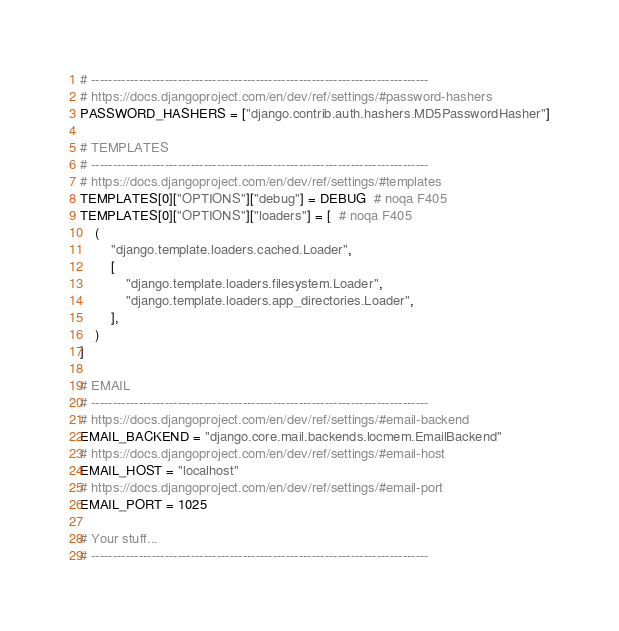<code> <loc_0><loc_0><loc_500><loc_500><_Python_># ------------------------------------------------------------------------------
# https://docs.djangoproject.com/en/dev/ref/settings/#password-hashers
PASSWORD_HASHERS = ["django.contrib.auth.hashers.MD5PasswordHasher"]

# TEMPLATES
# ------------------------------------------------------------------------------
# https://docs.djangoproject.com/en/dev/ref/settings/#templates
TEMPLATES[0]["OPTIONS"]["debug"] = DEBUG  # noqa F405
TEMPLATES[0]["OPTIONS"]["loaders"] = [  # noqa F405
    (
        "django.template.loaders.cached.Loader",
        [
            "django.template.loaders.filesystem.Loader",
            "django.template.loaders.app_directories.Loader",
        ],
    )
]

# EMAIL
# ------------------------------------------------------------------------------
# https://docs.djangoproject.com/en/dev/ref/settings/#email-backend
EMAIL_BACKEND = "django.core.mail.backends.locmem.EmailBackend"
# https://docs.djangoproject.com/en/dev/ref/settings/#email-host
EMAIL_HOST = "localhost"
# https://docs.djangoproject.com/en/dev/ref/settings/#email-port
EMAIL_PORT = 1025

# Your stuff...
# ------------------------------------------------------------------------------
</code> 